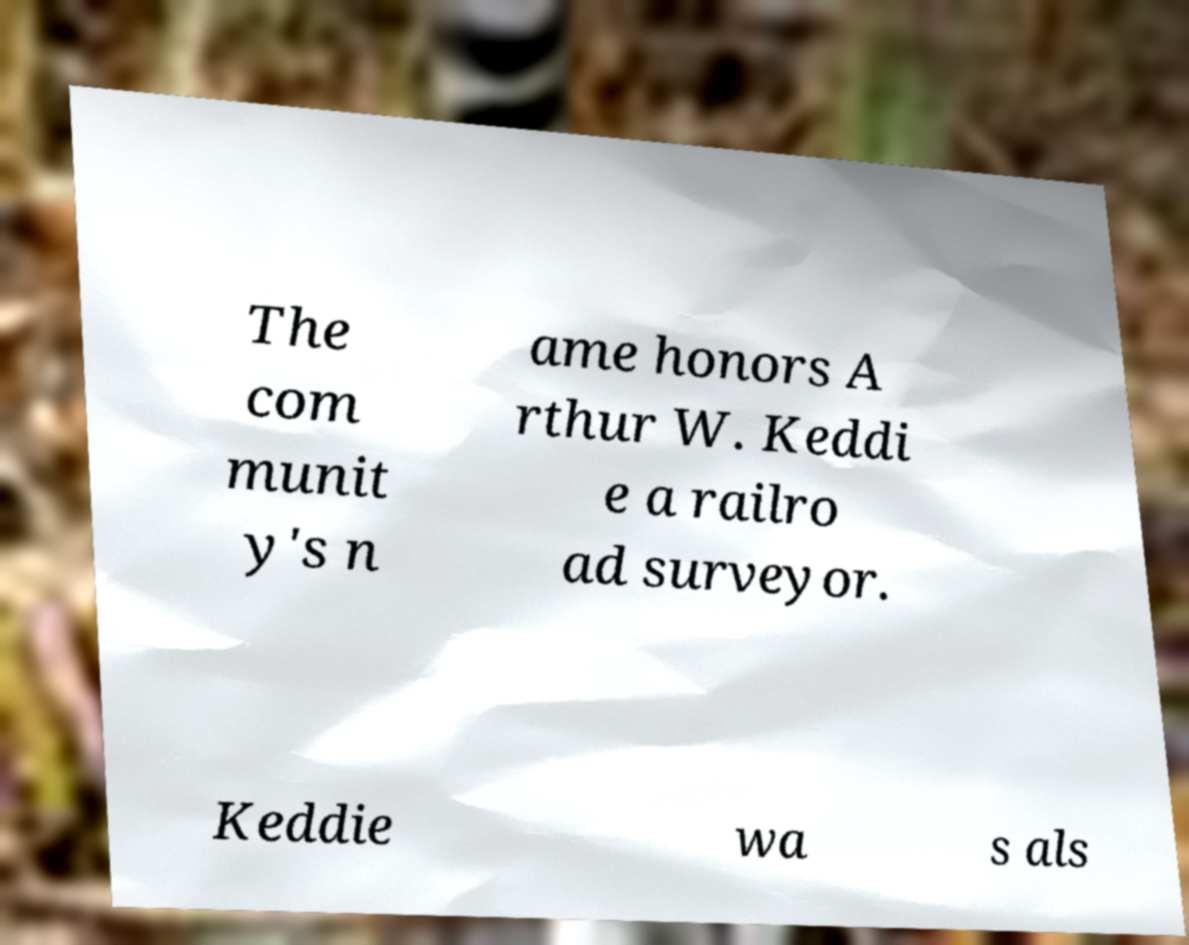Could you assist in decoding the text presented in this image and type it out clearly? The com munit y's n ame honors A rthur W. Keddi e a railro ad surveyor. Keddie wa s als 